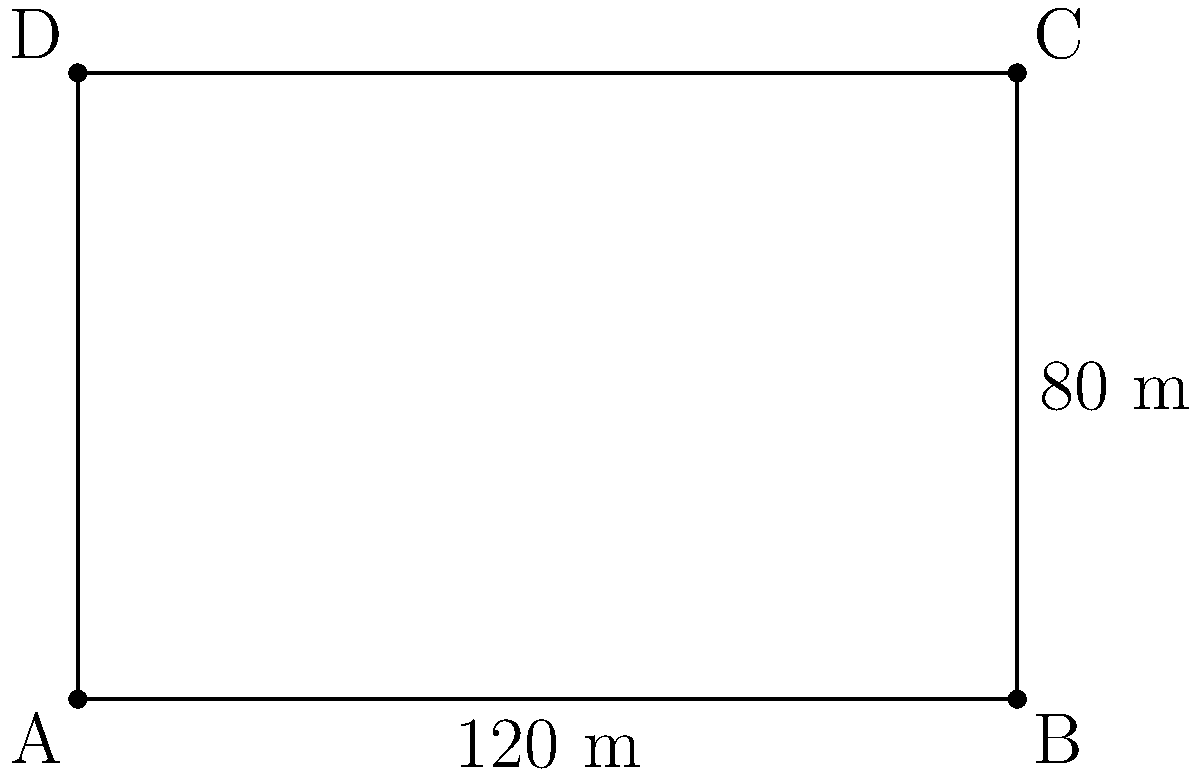A new government building is being proposed for legislation-related activities. The architectural plan shows a rectangular structure with dimensions of 120 meters in length and 80 meters in width. As part of the legislative process, you need to calculate the perimeter of this building. What is the total distance around the building's exterior? To calculate the perimeter of a rectangular building, we need to sum up the lengths of all four sides. Let's approach this step-by-step:

1. Identify the given dimensions:
   Length (l) = 120 meters
   Width (w) = 80 meters

2. Recall the formula for the perimeter of a rectangle:
   $P = 2l + 2w$, where $P$ is the perimeter, $l$ is the length, and $w$ is the width.

3. Substitute the values into the formula:
   $P = 2(120) + 2(80)$

4. Simplify:
   $P = 240 + 160$

5. Calculate the final result:
   $P = 400$

Therefore, the perimeter of the government building is 400 meters.
Answer: 400 meters 